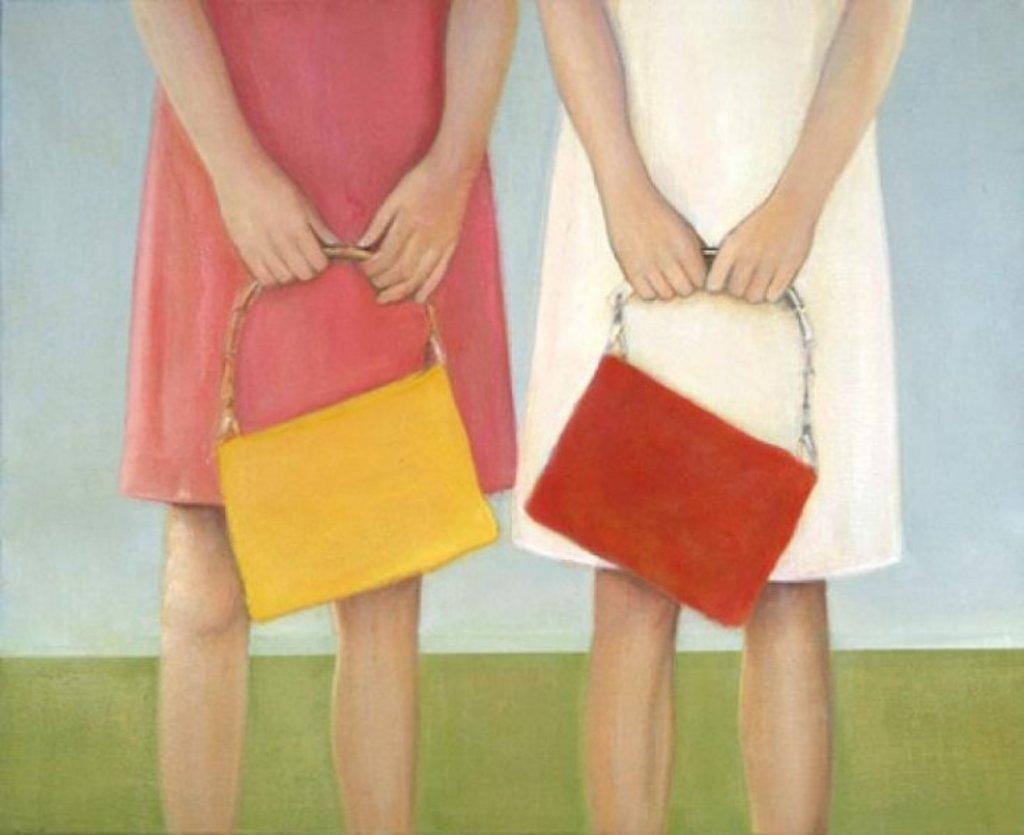How would you summarize this image in a sentence or two? This is a painting picture. Here we can see two girls wearing white and green colour dresses and holding red and yellow colour handbags with their hands. On the background we can see blue and green colour. 